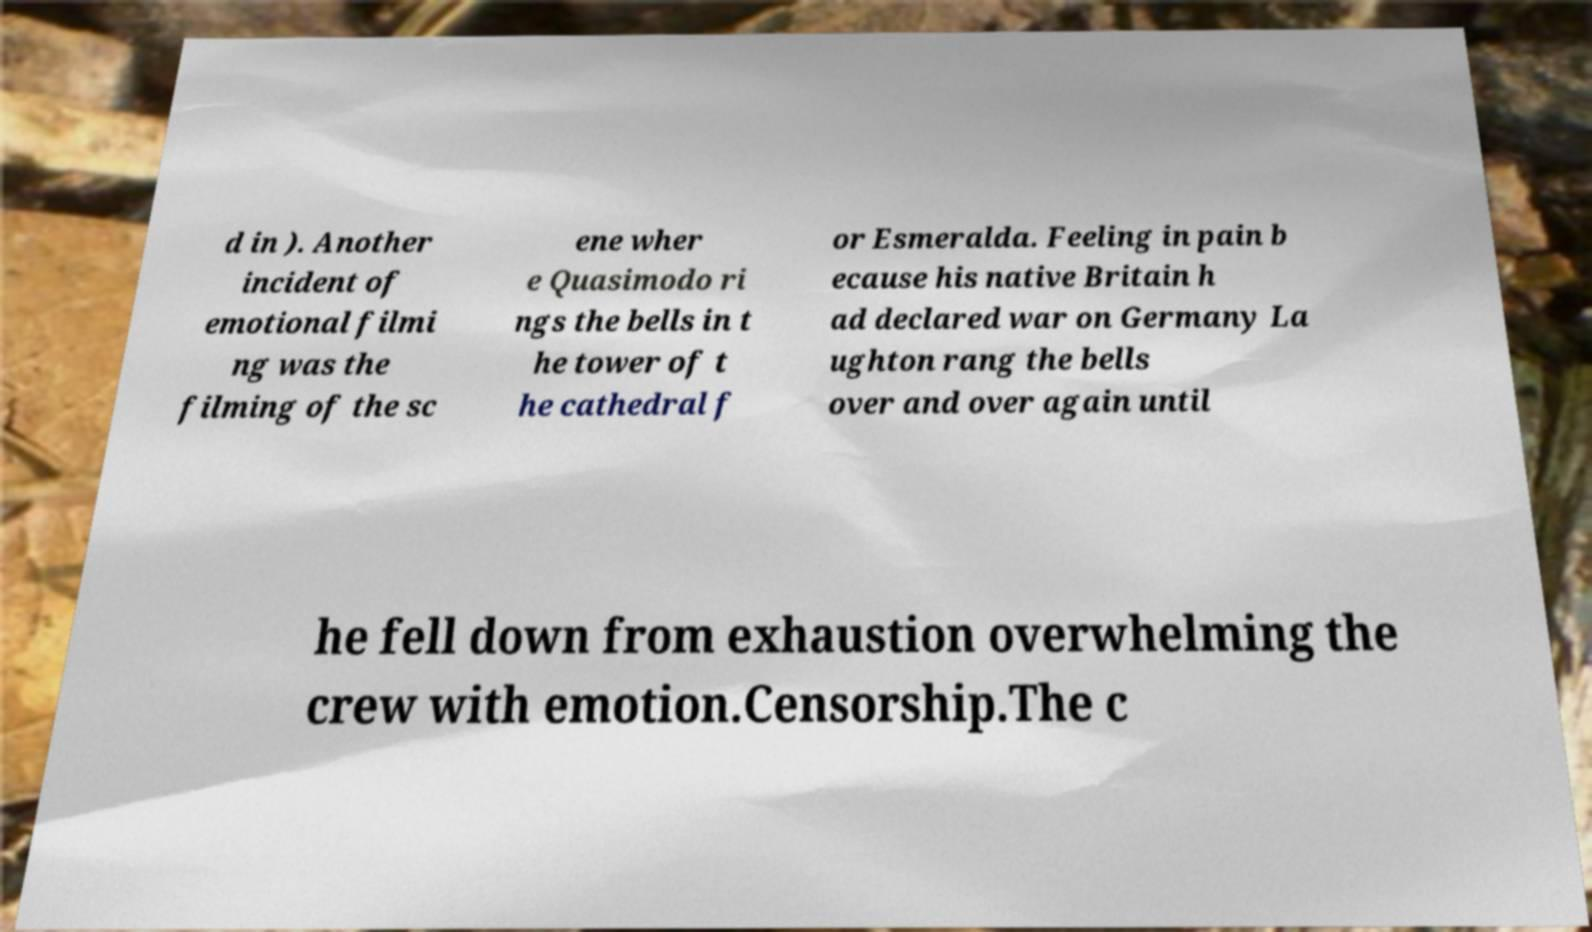Can you accurately transcribe the text from the provided image for me? d in ). Another incident of emotional filmi ng was the filming of the sc ene wher e Quasimodo ri ngs the bells in t he tower of t he cathedral f or Esmeralda. Feeling in pain b ecause his native Britain h ad declared war on Germany La ughton rang the bells over and over again until he fell down from exhaustion overwhelming the crew with emotion.Censorship.The c 